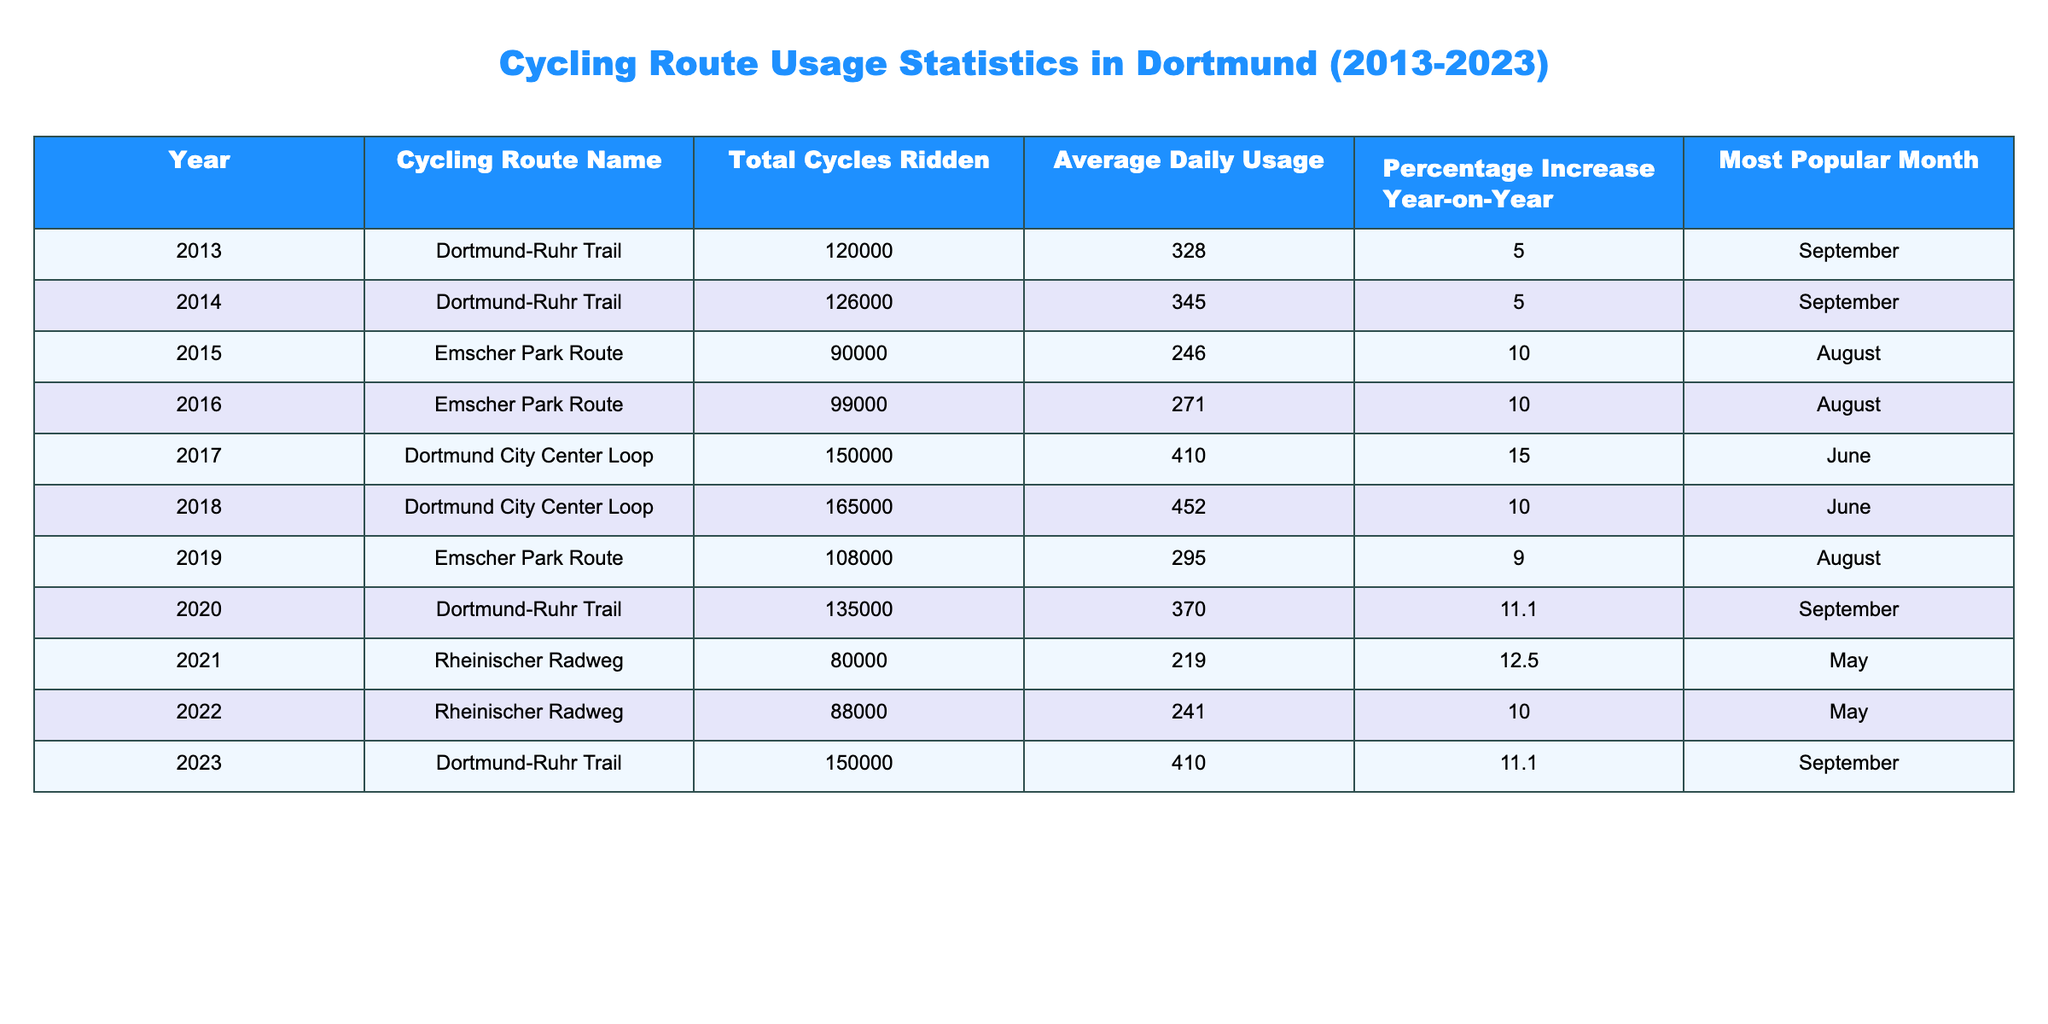What was the average daily usage of the Emscher Park Route in 2016? According to the table, the average daily usage for the Emscher Park Route in 2016 is listed as 271.
Answer: 271 Which cycling route had the highest total cycles ridden in 2023? The table shows the total cycles ridden for each route in 2023, and the Dortmund-Ruhr Trail had the highest number at 150,000.
Answer: Dortmund-Ruhr Trail Was there a percentage increase in the total cycles ridden on the Rheinischer Radweg from 2021 to 2022? In the table, the total cycles ridden for Rheinischer Radweg increased from 80,000 in 2021 to 88,000 in 2022. The percentage increase is calculated as [(88,000 - 80,000) / 80,000] * 100 = 10%. Therefore, the increase was indeed present.
Answer: Yes What was the percentage increase in total cycles ridden for the Dortmund-Ruhr Trail from 2013 to 2023? In 2013, the total cycles ridden were 120,000, and by 2023 it increased to 150,000. The percentage increase is calculated as [(150,000 - 120,000) / 120,000] * 100 = 25%.
Answer: 25% Which month was the most popular for cycling on the Emscher Park Route? The table indicates that August was consistently the most popular month for cycling on the Emscher Park Route in both 2015 and 2016.
Answer: August How many total cycles were ridden on the Dortmund City Center Loop in the years 2017 and 2018 combined? From the table, the total cycles for 2017 are 150,000 and for 2018 it is 165,000. Adding these together gives 150,000 + 165,000 = 315,000 cycles in total for these two years.
Answer: 315,000 In which year did the highest average daily usage occur for the Dortmund City Center Loop? Looking at the average daily usage for the Dortmund City Center Loop, 2018 shows the highest usage recorded at 452.
Answer: 2018 Did the cycling route usage generally increase or decrease from 2013 to 2023? An analysis of the total cycles ridden from 2013 to 2023 reveals a general increase in the total for most years compared to the previous year. Therefore, it is correct to say there was an overall increase.
Answer: Increase 